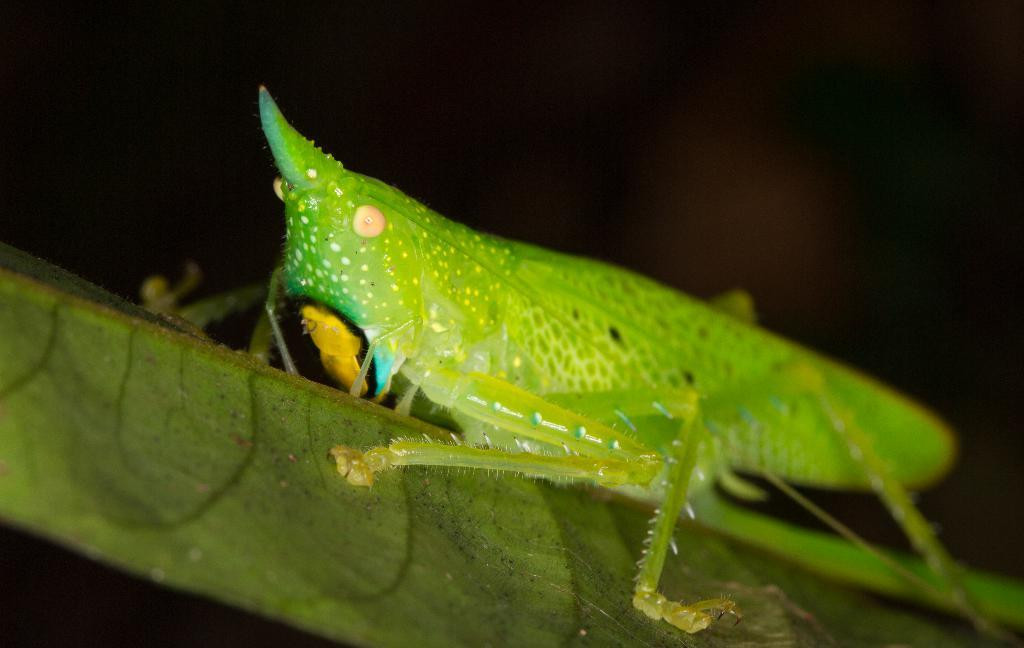What type of insect is in the image? There is a green color insect in the image. What color is the insect? The insect is green. What is the background color in the image? The background of the image is black. What type of carpenter is working on the thread in the image? There is no carpenter or thread present in the image; it features a green color insect against a black background. 